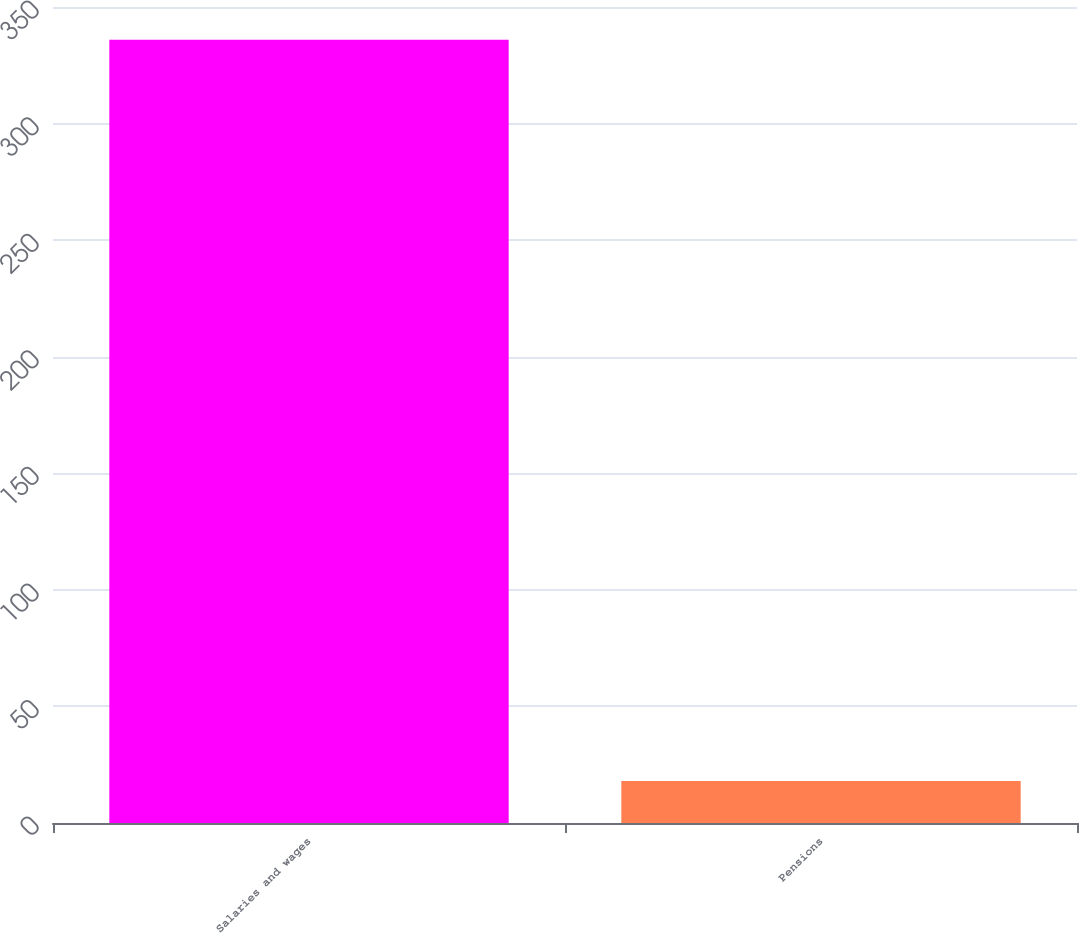Convert chart. <chart><loc_0><loc_0><loc_500><loc_500><bar_chart><fcel>Salaries and wages<fcel>Pensions<nl><fcel>336<fcel>18<nl></chart> 